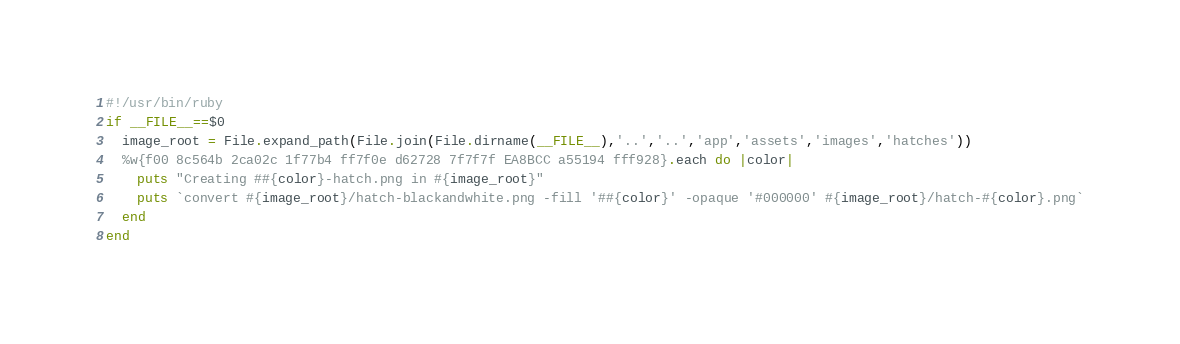<code> <loc_0><loc_0><loc_500><loc_500><_Ruby_>#!/usr/bin/ruby
if __FILE__==$0
  image_root = File.expand_path(File.join(File.dirname(__FILE__),'..','..','app','assets','images','hatches'))
  %w{f00 8c564b 2ca02c 1f77b4 ff7f0e d62728 7f7f7f EA8BCC a55194 fff928}.each do |color|
    puts "Creating ##{color}-hatch.png in #{image_root}"
    puts `convert #{image_root}/hatch-blackandwhite.png -fill '##{color}' -opaque '#000000' #{image_root}/hatch-#{color}.png`
  end
end</code> 